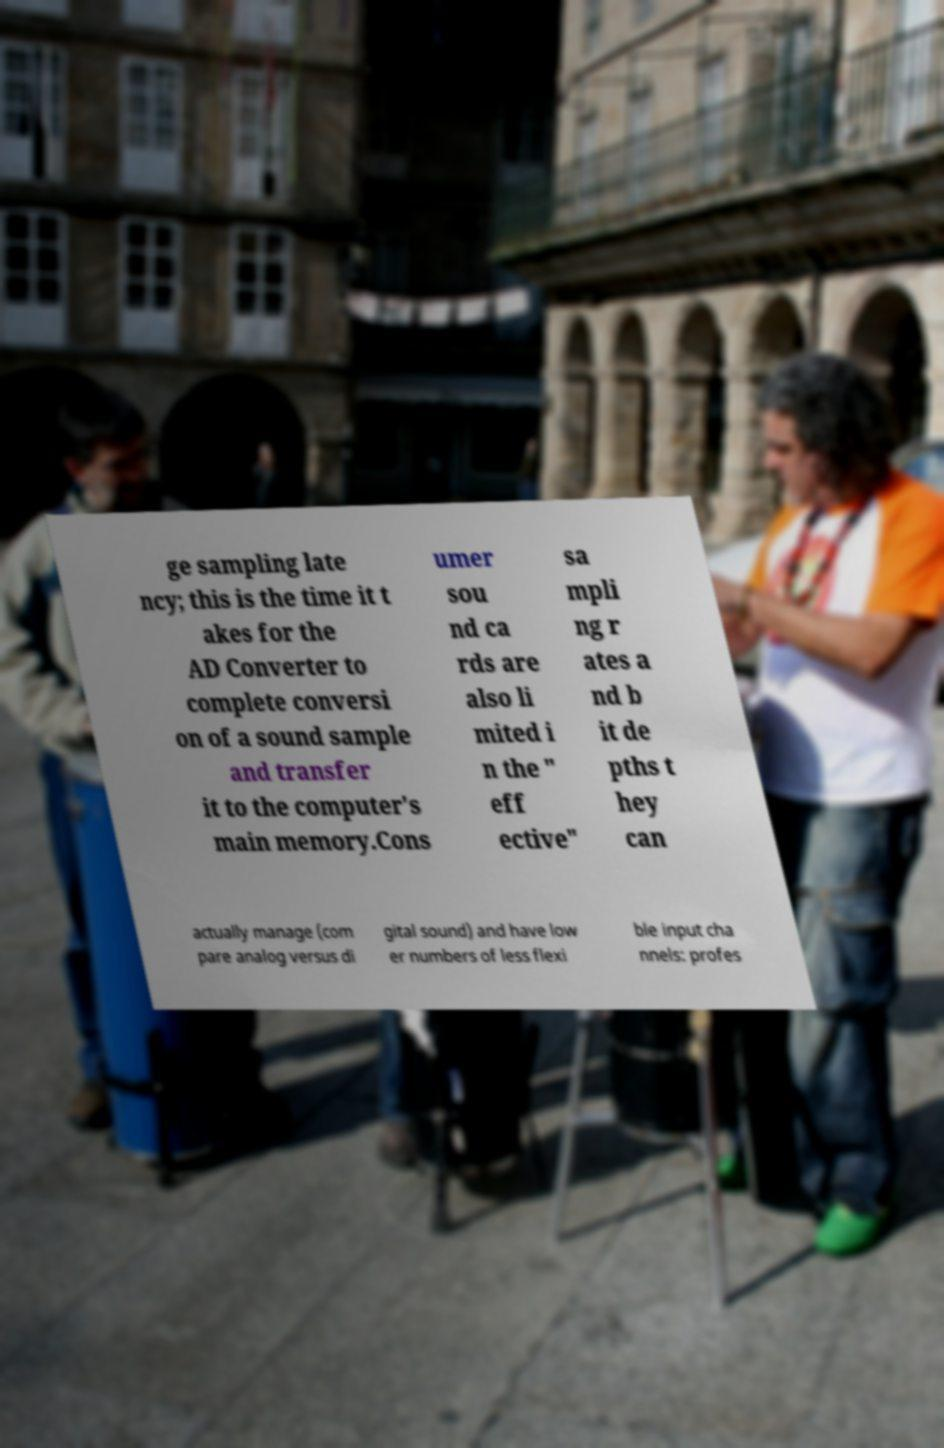Can you read and provide the text displayed in the image?This photo seems to have some interesting text. Can you extract and type it out for me? ge sampling late ncy; this is the time it t akes for the AD Converter to complete conversi on of a sound sample and transfer it to the computer's main memory.Cons umer sou nd ca rds are also li mited i n the " eff ective" sa mpli ng r ates a nd b it de pths t hey can actually manage (com pare analog versus di gital sound) and have low er numbers of less flexi ble input cha nnels: profes 